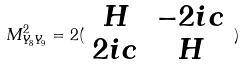Convert formula to latex. <formula><loc_0><loc_0><loc_500><loc_500>M _ { Y _ { 8 } Y _ { 9 } } ^ { 2 } = 2 ( \begin{array} { c c } H & - 2 i c \\ 2 i c & H \end{array} )</formula> 